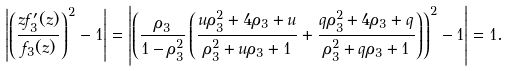Convert formula to latex. <formula><loc_0><loc_0><loc_500><loc_500>& \left | \left ( \frac { z f _ { 3 } ^ { \prime } ( z ) } { f _ { 3 } ( z ) } \right ) ^ { 2 } - 1 \right | = \left | \left ( \frac { \rho _ { 3 } } { 1 - \rho _ { 3 } ^ { 2 } } \left ( \frac { u \rho _ { 3 } ^ { 2 } + 4 \rho _ { 3 } + u } { \rho _ { 3 } ^ { 2 } + u \rho _ { 3 } + 1 } + \frac { q \rho _ { 3 } ^ { 2 } + 4 \rho _ { 3 } + q } { \rho _ { 3 } ^ { 2 } + q \rho _ { 3 } + 1 } \right ) \right ) ^ { 2 } - 1 \right | = 1 .</formula> 